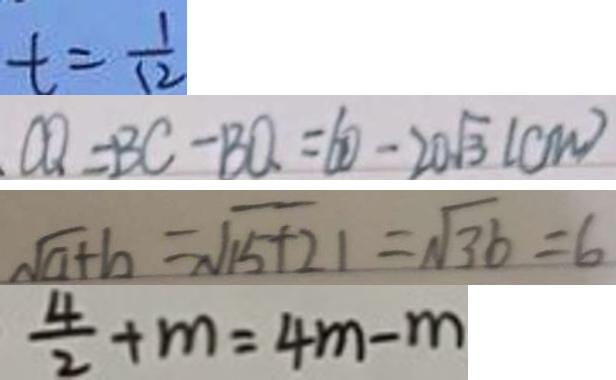Convert formula to latex. <formula><loc_0><loc_0><loc_500><loc_500>t = \frac { 1 } { 1 2 } 
 C Q = B C - B O = 6 0 - 2 0 \sqrt { 3 } ( c m ) 
 \sqrt { a + b } = \sqrt { 1 5 + 2 1 } = \sqrt { 3 6 } = 6 
 \frac { 4 } { 2 } + m = 4 m - m</formula> 